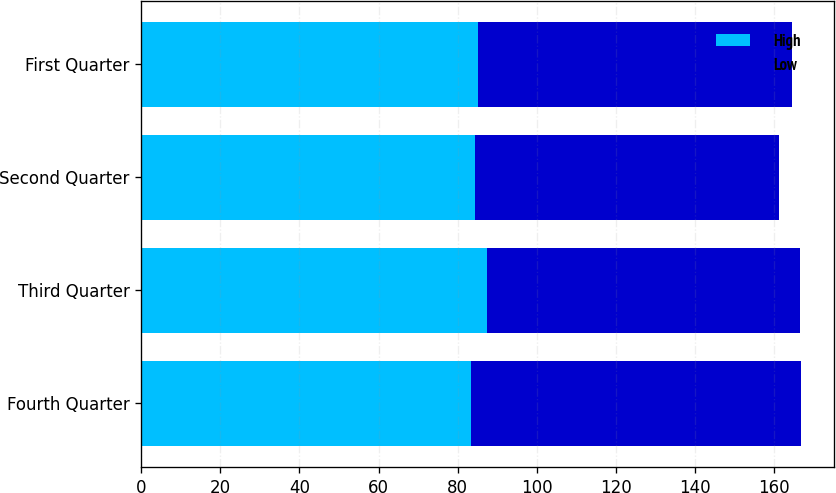<chart> <loc_0><loc_0><loc_500><loc_500><stacked_bar_chart><ecel><fcel>Fourth Quarter<fcel>Third Quarter<fcel>Second Quarter<fcel>First Quarter<nl><fcel>High<fcel>83.33<fcel>87.32<fcel>84.37<fcel>85.19<nl><fcel>Low<fcel>83.33<fcel>79.23<fcel>76.75<fcel>79.35<nl></chart> 